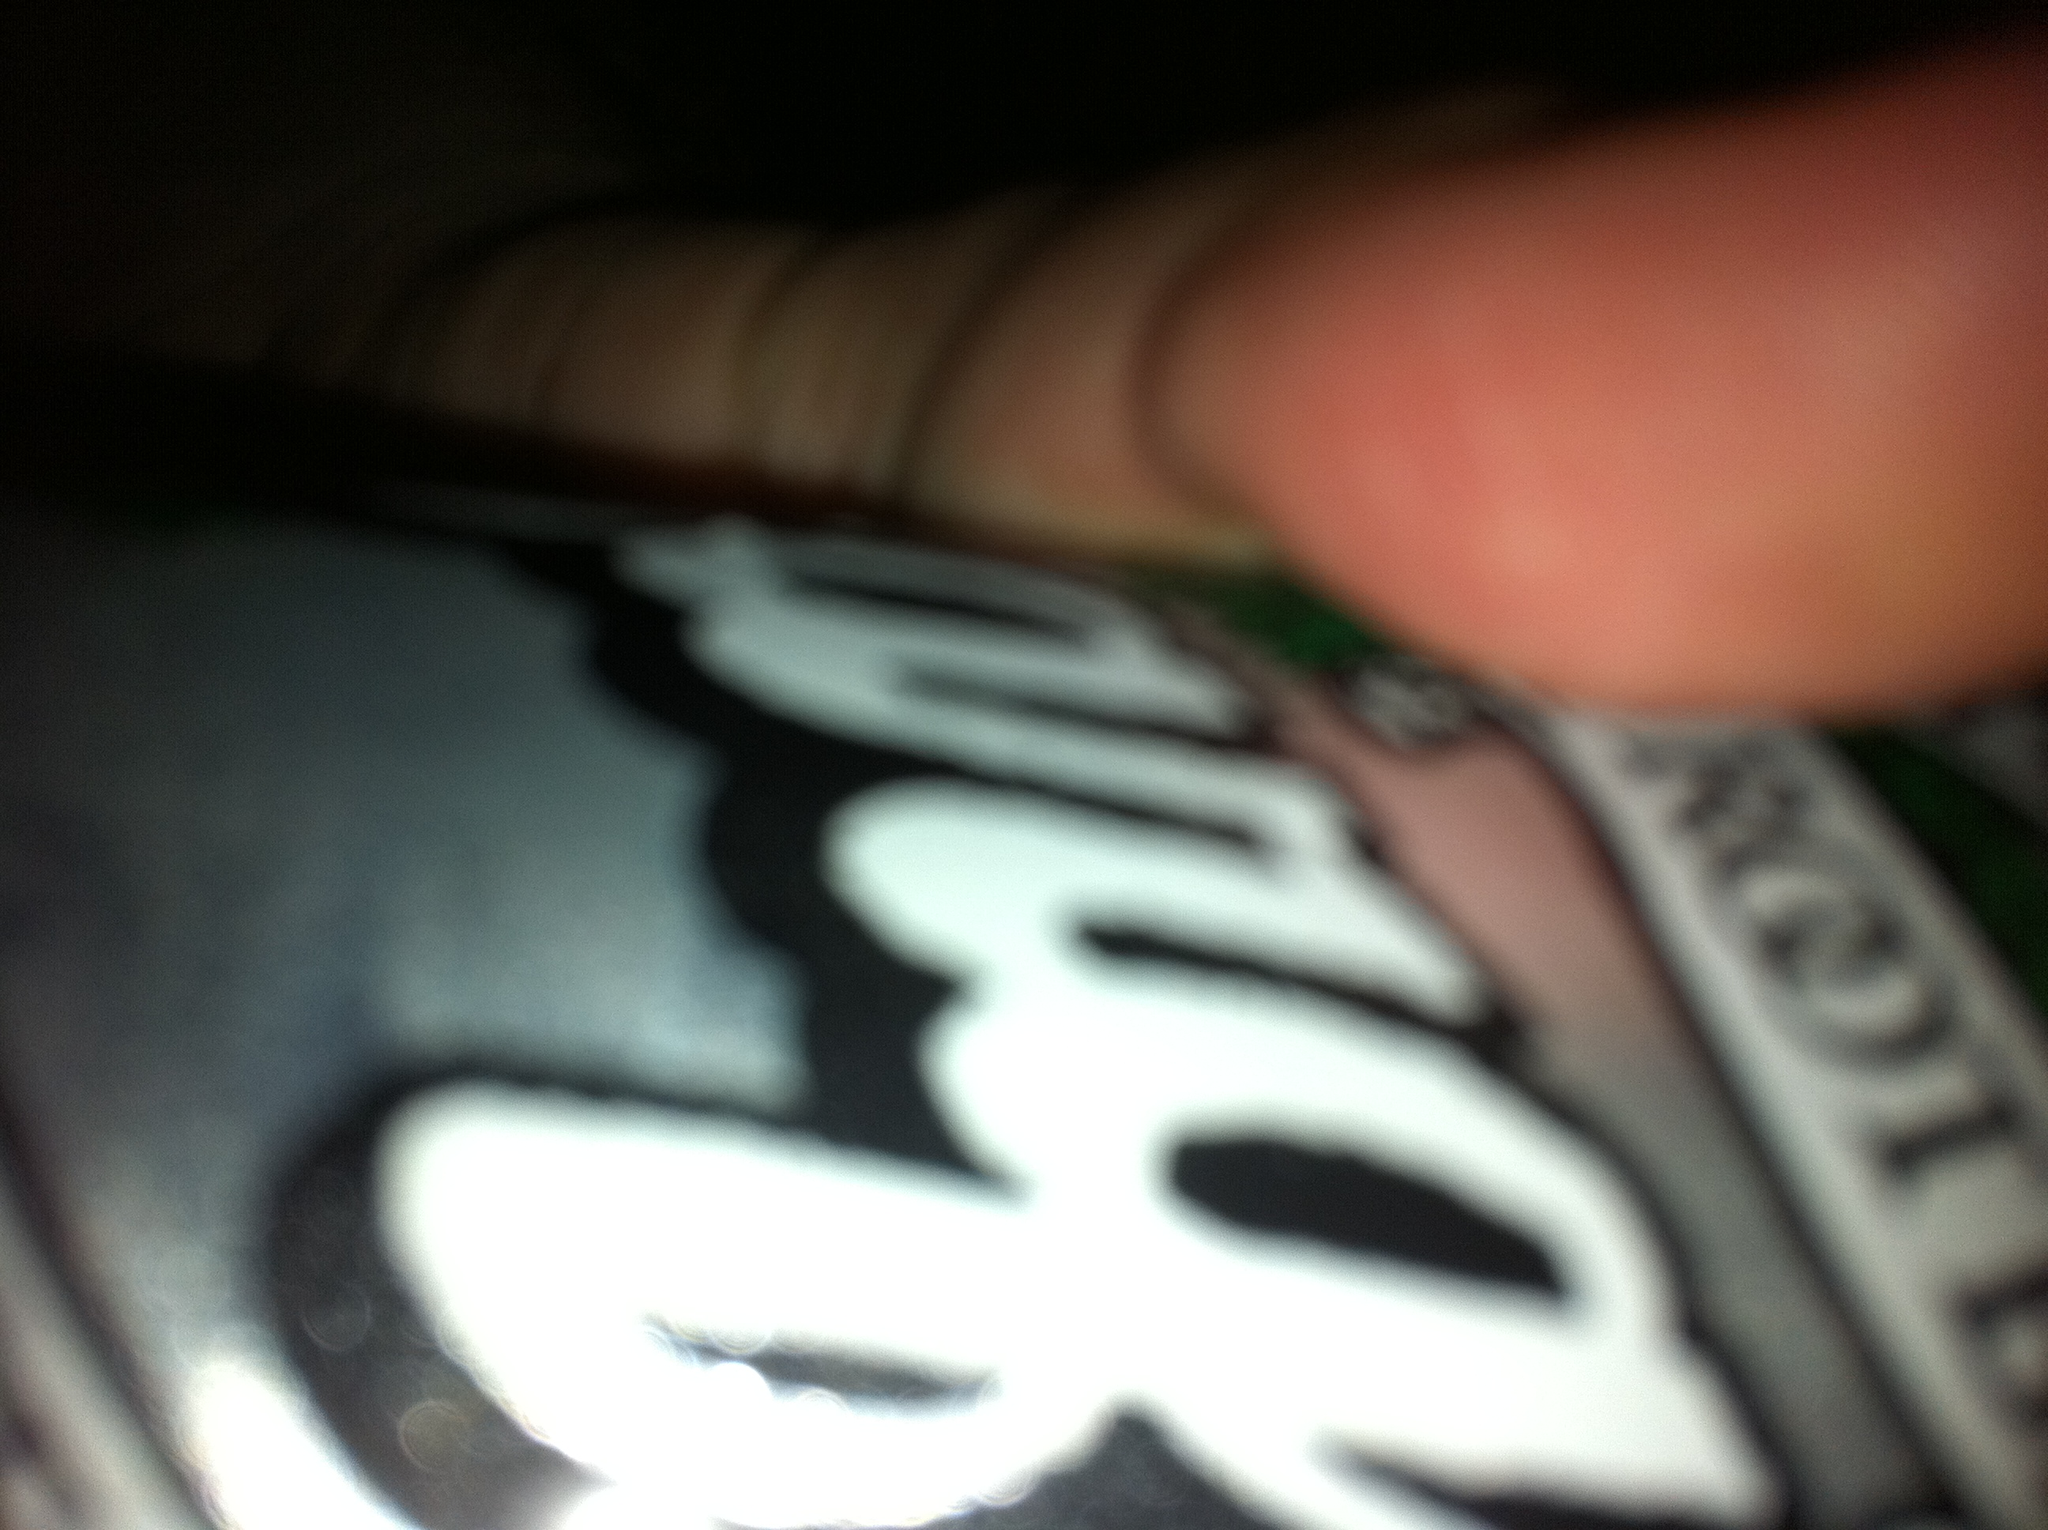Imagine you're having a nostalgic moment enjoying this root beer. Describe it. As I take a sip of this fizzy root beer, I am instantly transported back to a warm summer evening from my childhood. The gentle hum of crickets fills the air, and the cool breeze carries the scent of freshly cut grass. I’m sitting on the front porch with my friends, laughter echoing as we share stories and games. The taste of the root beer, sweet and creamy, is a comforting reminder of those carefree days. It’s a moment of pure nostalgia, where the complexities of life fade away, and I’m left with the simple joy of the present. 